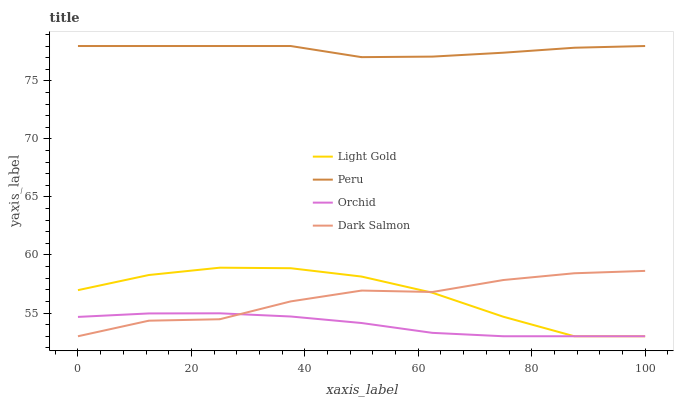Does Orchid have the minimum area under the curve?
Answer yes or no. Yes. Does Peru have the maximum area under the curve?
Answer yes or no. Yes. Does Dark Salmon have the minimum area under the curve?
Answer yes or no. No. Does Dark Salmon have the maximum area under the curve?
Answer yes or no. No. Is Orchid the smoothest?
Answer yes or no. Yes. Is Dark Salmon the roughest?
Answer yes or no. Yes. Is Peru the smoothest?
Answer yes or no. No. Is Peru the roughest?
Answer yes or no. No. Does Peru have the lowest value?
Answer yes or no. No. Does Dark Salmon have the highest value?
Answer yes or no. No. Is Orchid less than Peru?
Answer yes or no. Yes. Is Peru greater than Dark Salmon?
Answer yes or no. Yes. Does Orchid intersect Peru?
Answer yes or no. No. 